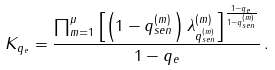Convert formula to latex. <formula><loc_0><loc_0><loc_500><loc_500>K _ { q _ { e } } = \frac { \prod _ { m = 1 } ^ { \mu } \left [ \left ( 1 - q ^ { ( m ) } _ { s e n } \right ) \lambda ^ { ( m ) } _ { q ^ { ( m ) } _ { s e n } } \right ] ^ { \frac { 1 - q _ { e } } { 1 - q ^ { ( m ) } _ { s e n } } } } { 1 - q _ { e } } \, .</formula> 